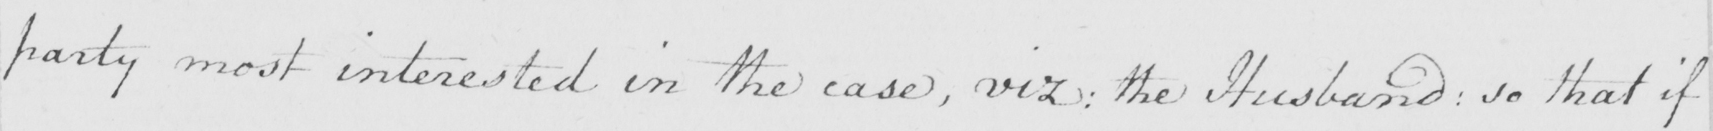Can you read and transcribe this handwriting? party most interested in the case , viz :  the Husband :  so that if 